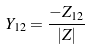<formula> <loc_0><loc_0><loc_500><loc_500>Y _ { 1 2 } = \frac { - Z _ { 1 2 } } { | Z | }</formula> 